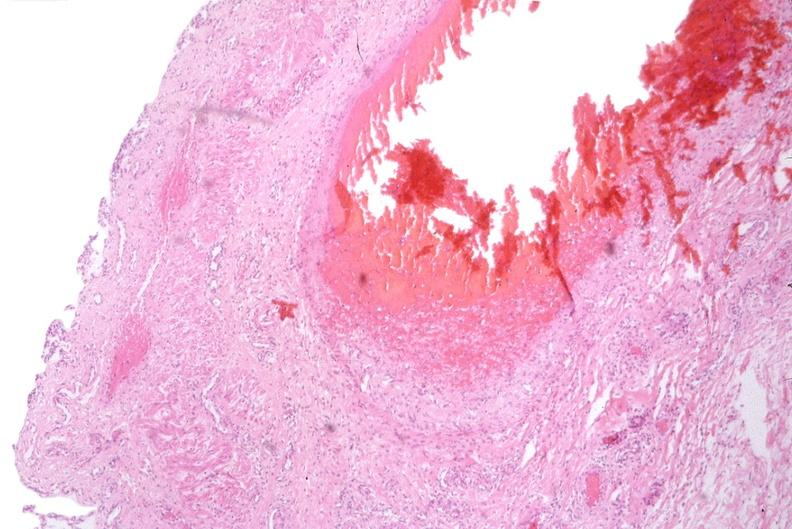what does this image show?
Answer the question using a single word or phrase. Esophogus 